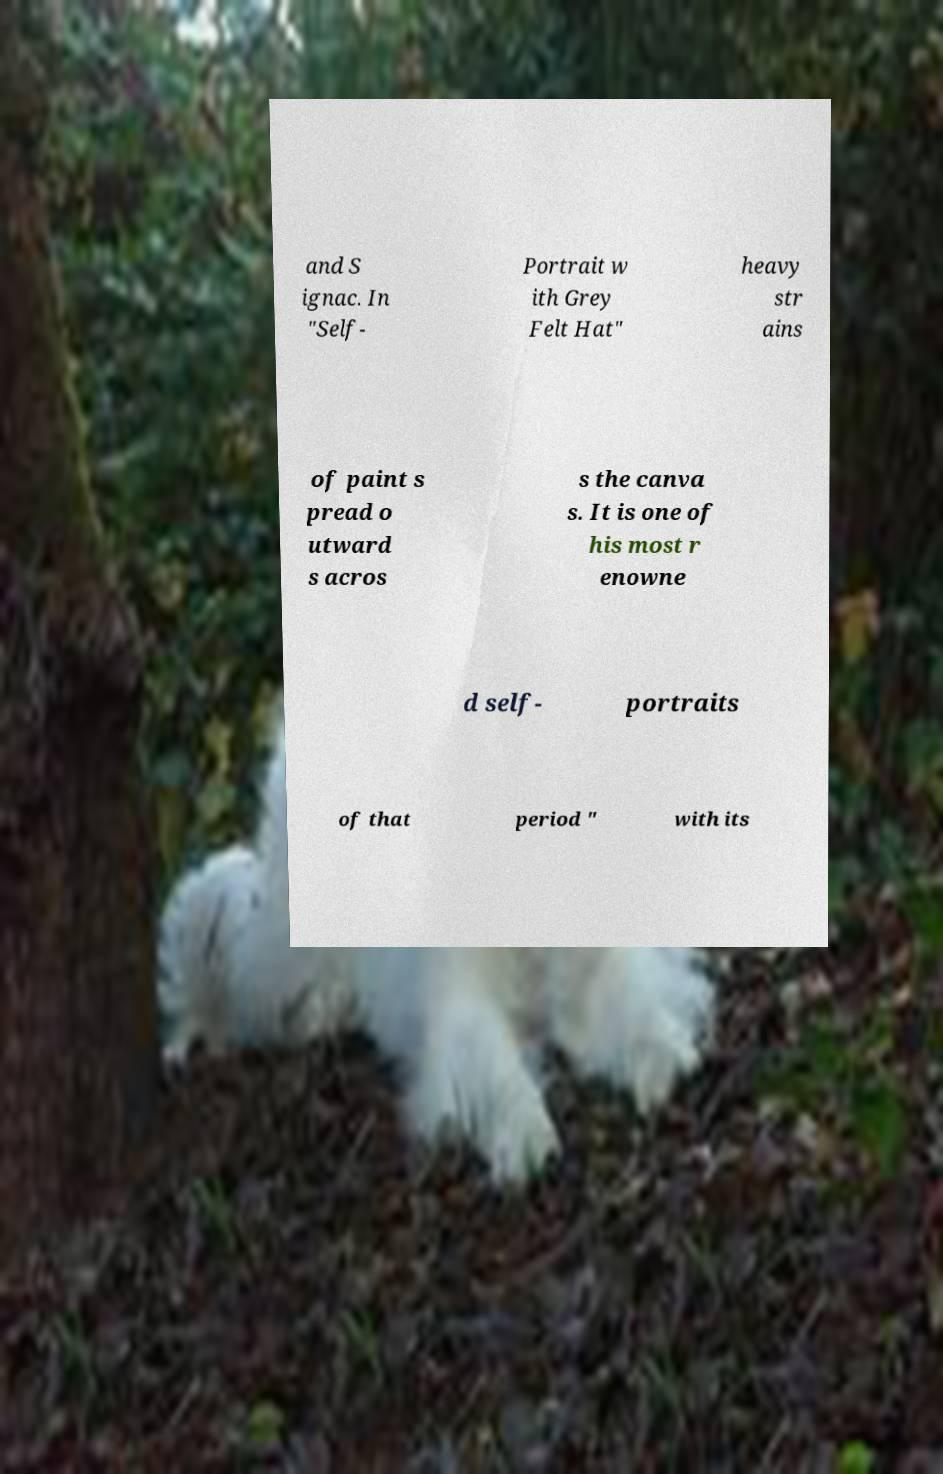Please identify and transcribe the text found in this image. and S ignac. In "Self- Portrait w ith Grey Felt Hat" heavy str ains of paint s pread o utward s acros s the canva s. It is one of his most r enowne d self- portraits of that period " with its 